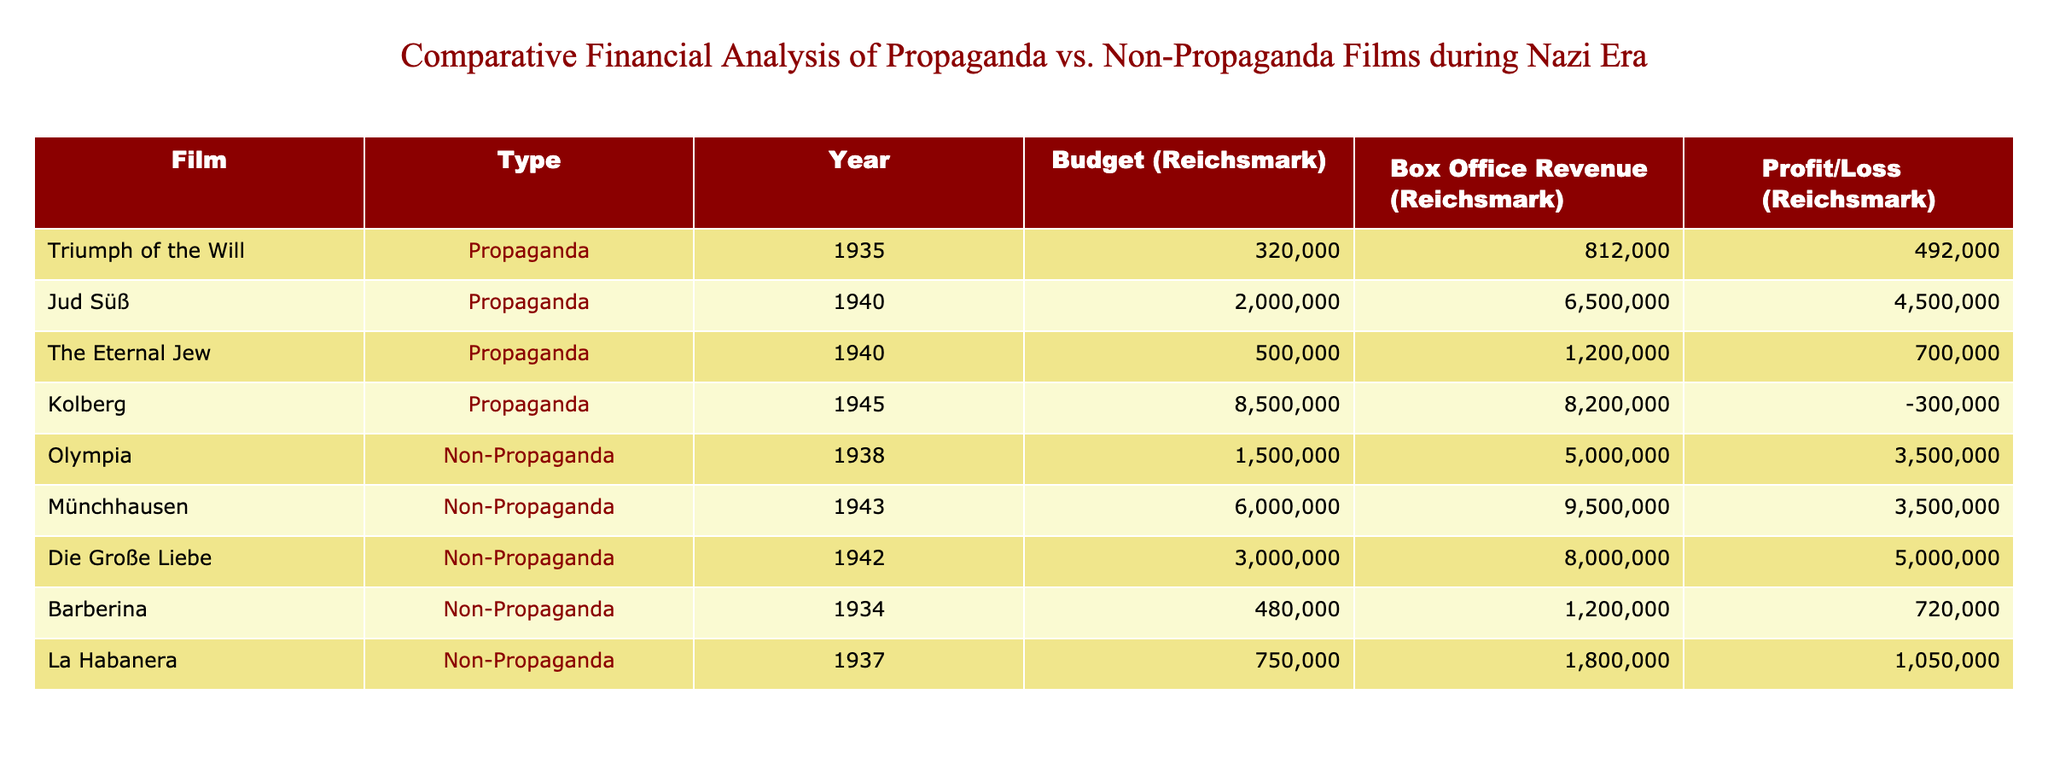What is the budget for the film "Jud Süß"? The budget for "Jud Süß" can be found in the "Budget (Reichsmark)" column corresponding to this film. It shows that the budget is 2,000,000 Reichsmark.
Answer: 2,000,000 Reichsmark Which propaganda film had the highest profit? By checking the "Profit/Loss (Reichsmark)" column of each propaganda film, "Jud Süß" has the highest profit of 4,500,000 Reichsmark.
Answer: Jud Süß What is the total profit/loss for non-propaganda films? Summing up the profits from all non-propaganda films, we find: 3,500,000 + 3,500,000 + 5,000,000 + 720,000 + 1,050,000 = 14,770,000 Reichsmark. Therefore, the total profit/loss is 14,770,000 Reichsmark.
Answer: 14,770,000 Reichsmark Did "Triumph of the Will" make any profit? "Triumph of the Will" has a profit of 492,000 Reichsmark, which is greater than zero, indicating it did indeed make a profit.
Answer: Yes What is the average budget of propaganda films? The budgets for propaganda films are 320,000 + 2,000,000 + 500,000 + 8,500,000. This sums to 11,320,000. There are 4 propaganda films, so the average budget is 11,320,000 / 4 = 2,830,000 Reichsmark.
Answer: 2,830,000 Reichsmark Which type of film (propaganda or non-propaganda) had higher average box office revenue? Calculating the box office revenues, the sum for propaganda films is 8,000 + 6,500,000 + 1,200,000 + 8,200,000 = 15,900,000, and for non-propaganda films: 5,000,000 + 9,500,000 + 8,000,000 + 1,200,000 + 1,800,000 = 25,500,000. There are 4 propaganda and 5 non-propaganda films, so average for propaganda is 15,900,000 / 4 = 3,975,000 and for non-propaganda it is 25,500,000 / 5 = 5,100,000. Non-propaganda films had a higher average revenue.
Answer: Non-propaganda films Are there any films with negative profit in the propaganda category? Checking the "Profit/Loss (Reichsmark)" for propaganda films, we see "Kolberg" has a profit of -300,000, which indicates a loss.
Answer: Yes Which film had the largest budget and did it yield a profit or loss? The film with the largest budget is "Kolberg" at 8,500,000 Reichsmark, and it resulted in a loss of 300,000 Reichsmark, as seen in the profit column.
Answer: Loss 